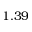Convert formula to latex. <formula><loc_0><loc_0><loc_500><loc_500>1 . 3 9</formula> 